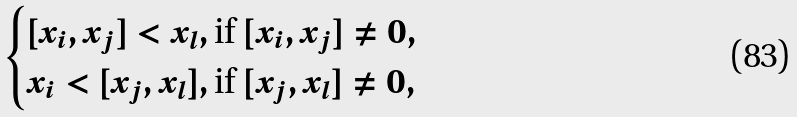<formula> <loc_0><loc_0><loc_500><loc_500>\begin{cases} [ x _ { i } , x _ { j } ] < x _ { l } , \text {if               } [ x _ { i } , x _ { j } ] \neq 0 , \\ x _ { i } < [ x _ { j } , x _ { l } ] , \text {if               } [ x _ { j } , x _ { l } ] \neq 0 , \end{cases}</formula> 